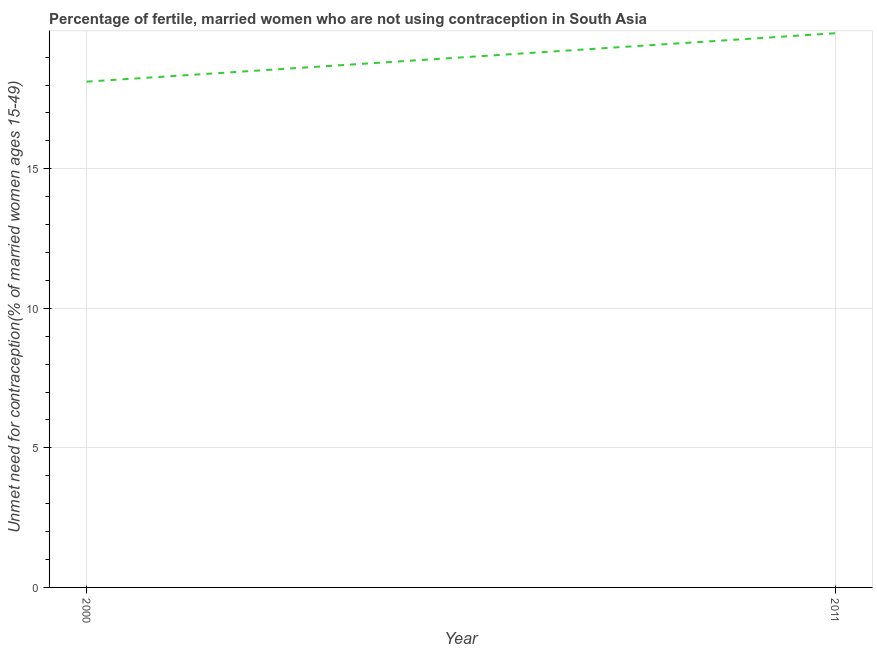What is the number of married women who are not using contraception in 2011?
Give a very brief answer. 19.86. Across all years, what is the maximum number of married women who are not using contraception?
Ensure brevity in your answer.  19.86. Across all years, what is the minimum number of married women who are not using contraception?
Give a very brief answer. 18.12. What is the sum of the number of married women who are not using contraception?
Offer a very short reply. 37.98. What is the difference between the number of married women who are not using contraception in 2000 and 2011?
Give a very brief answer. -1.73. What is the average number of married women who are not using contraception per year?
Offer a very short reply. 18.99. What is the median number of married women who are not using contraception?
Give a very brief answer. 18.99. Do a majority of the years between 2011 and 2000 (inclusive) have number of married women who are not using contraception greater than 7 %?
Provide a succinct answer. No. What is the ratio of the number of married women who are not using contraception in 2000 to that in 2011?
Offer a very short reply. 0.91. In how many years, is the number of married women who are not using contraception greater than the average number of married women who are not using contraception taken over all years?
Offer a terse response. 1. Does the graph contain grids?
Ensure brevity in your answer.  Yes. What is the title of the graph?
Make the answer very short. Percentage of fertile, married women who are not using contraception in South Asia. What is the label or title of the X-axis?
Ensure brevity in your answer.  Year. What is the label or title of the Y-axis?
Keep it short and to the point.  Unmet need for contraception(% of married women ages 15-49). What is the  Unmet need for contraception(% of married women ages 15-49) of 2000?
Offer a very short reply. 18.12. What is the  Unmet need for contraception(% of married women ages 15-49) of 2011?
Offer a very short reply. 19.86. What is the difference between the  Unmet need for contraception(% of married women ages 15-49) in 2000 and 2011?
Ensure brevity in your answer.  -1.73. 